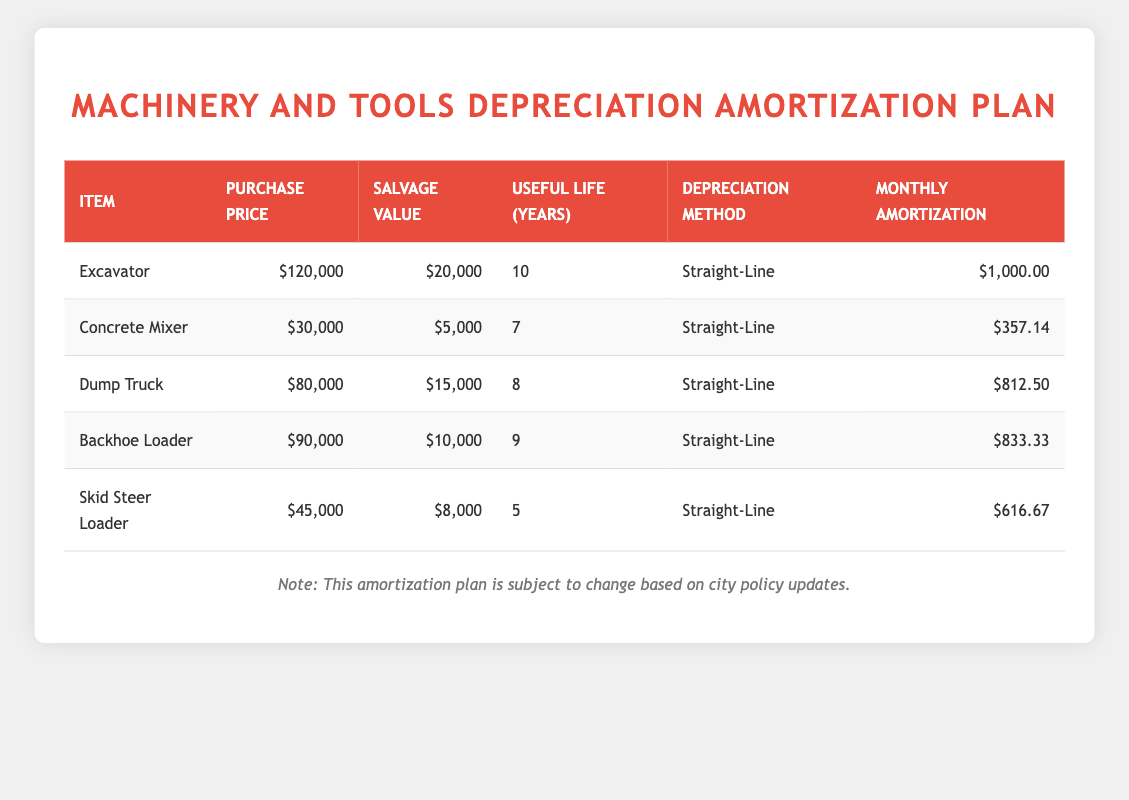What is the purchase price of the Excavator? The purchase price of the Excavator is listed in the corresponding row for this item. It is shown as $120,000.
Answer: $120,000 How much is the monthly amortization for the Concrete Mixer? The monthly amortization for the Concrete Mixer can be found directly in its row within the table, where it is listed as $357.14.
Answer: $357.14 Which item has the longest useful life, and how many years is it? By inspecting the "Useful Life (Years)" column, the Excavator has the longest useful life of 10 years, more than any other item listed.
Answer: Excavator, 10 years Is the salvage value of the Dump Truck greater than that of the Backhoe Loader? The salvage value of the Dump Truck is $15,000, while the salvage value of the Backhoe Loader is $10,000. Since $15,000 is greater than $10,000, the statement is true.
Answer: Yes Calculate the total monthly amortization for all items combined. To find the total monthly amortization, you sum up the amortization values for all items: $1,000 + $357.14 + $812.50 + $833.33 + $616.67 = $3,619.64.
Answer: $3,619.64 Which item has the highest salvage value? Comparing the salvage values: Excavator ($20,000), Concrete Mixer ($5,000), Dump Truck ($15,000), Backhoe Loader ($10,000), and Skid Steer Loader ($8,000), the Excavator has the highest salvage value of $20,000.
Answer: Excavator, $20,000 What is the average monthly amortization for all machinery and tools? To find the average, sum the monthly amortization amounts: $1,000 + $357.14 + $812.50 + $833.33 + $616.67 = $3,619.64. Then divide by the total number of items, which is 5: $3,619.64 / 5 = $723.93.
Answer: $723.93 Is the monthly amortization for Skid Steer Loader less than $600? The monthly amortization for Skid Steer Loader is $616.67, which is greater than $600. Hence, the statement is false.
Answer: No Which item has the shortest useful life among the items listed? By examining the table, the shortest useful life belongs to the Skid Steer Loader, which has a useful life of 5 years, less than any other item.
Answer: Skid Steer Loader, 5 years 